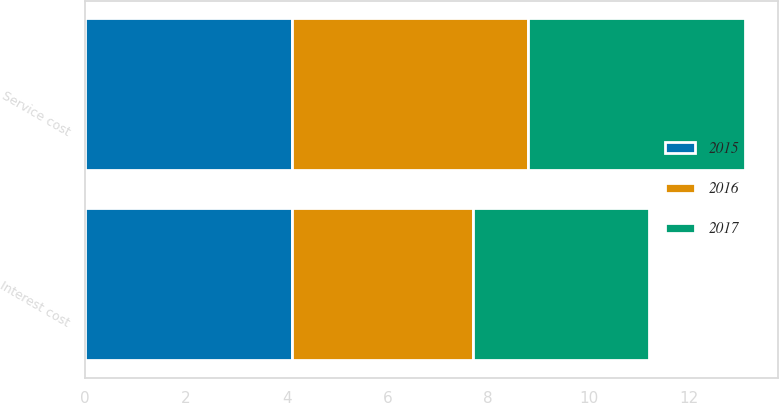<chart> <loc_0><loc_0><loc_500><loc_500><stacked_bar_chart><ecel><fcel>Service cost<fcel>Interest cost<nl><fcel>2017<fcel>4.3<fcel>3.5<nl><fcel>2016<fcel>4.7<fcel>3.6<nl><fcel>2015<fcel>4.1<fcel>4.1<nl></chart> 